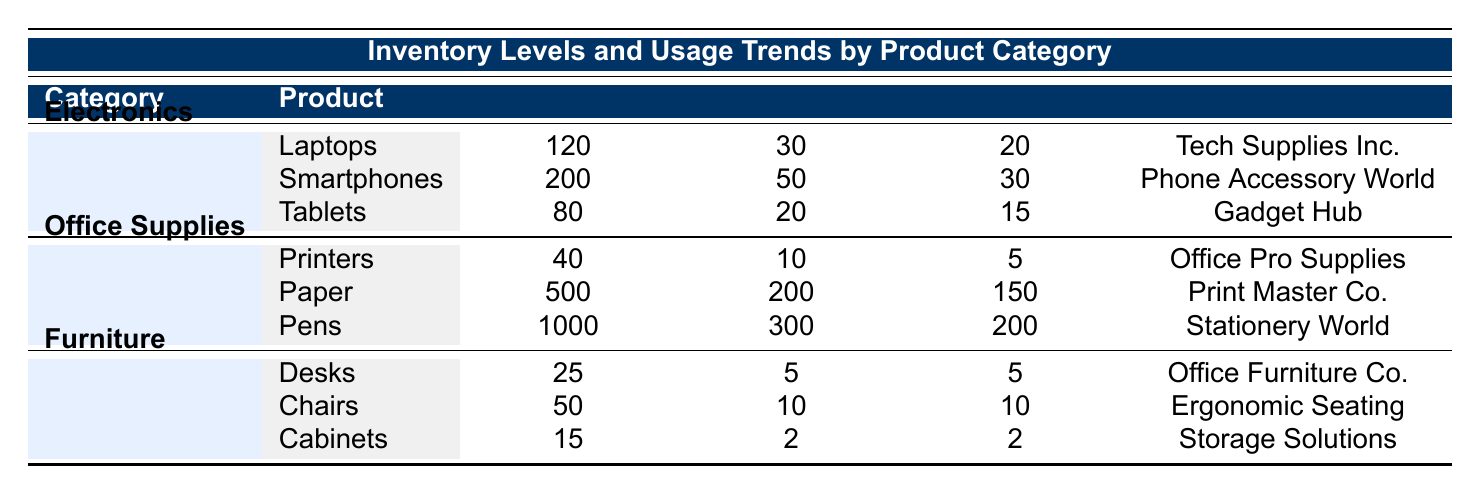What is the current stock of Laptops? The table indicates the "Current Stock" for Laptops under the Electronics category, which is explicitly listed as 120.
Answer: 120 Which product has the highest current stock? Looking at the "Current Stock" data across all categories, the maximum value is 1000 for Pens under Office Supplies.
Answer: Pens Is the monthly usage of Tablets greater than 15? The "Monthly Usage" for Tablets is stated as 20, which is indeed greater than 15.
Answer: Yes What is the total current stock of Office Supplies? The current stocks for Printers, Paper, and Pens are 40, 500, and 1000 respectively. Summing these gives 40 + 500 + 1000 = 1540.
Answer: 1540 Are there any products in the Furniture category that have a reorder level of 5 or less? The reorder levels for Furniture products are as follows: Desks is 5, Chairs is 10, and Cabinets is 2. Since Desks and Cabinets both meet the criteria, the answer is yes.
Answer: Yes What is the average monthly usage of all Electronics products? The monthly usages for Electronics are 30 (Laptops), 50 (Smartphones), and 20 (Tablets). The sum is 30 + 50 + 20 = 100. There are 3 products, so the average is 100 / 3 = 33.33.
Answer: 33.33 Which office supply has the lowest current stock and what is its value? The "Current Stock" values for office supplies are 40 (Printers), 500 (Paper), and 1000 (Pens). The lowest stock is for Printers at 40.
Answer: 40 What is the difference in monthly usage between Paper and Pens? The monthly usage of Paper is 200 and of Pens is 300. The difference is 300 - 200 = 100.
Answer: 100 Is the reorder level for Chairs less than or equal to 10? The reorder level for Chairs is provided as 10. Since it is equal, the answer is yes.
Answer: Yes 